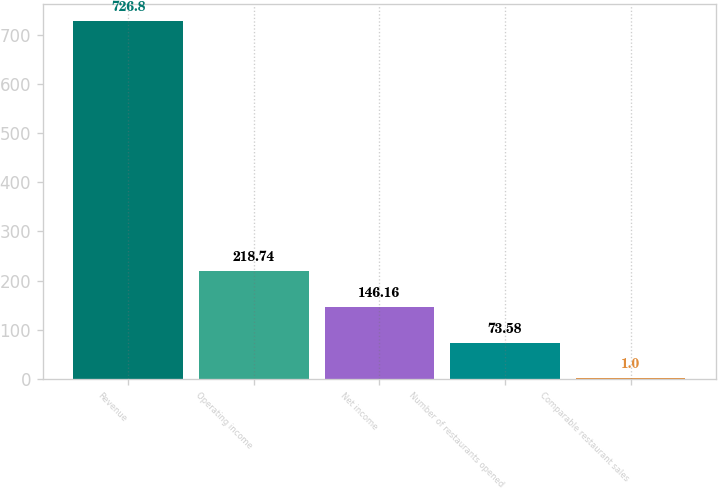<chart> <loc_0><loc_0><loc_500><loc_500><bar_chart><fcel>Revenue<fcel>Operating income<fcel>Net income<fcel>Number of restaurants opened<fcel>Comparable restaurant sales<nl><fcel>726.8<fcel>218.74<fcel>146.16<fcel>73.58<fcel>1<nl></chart> 